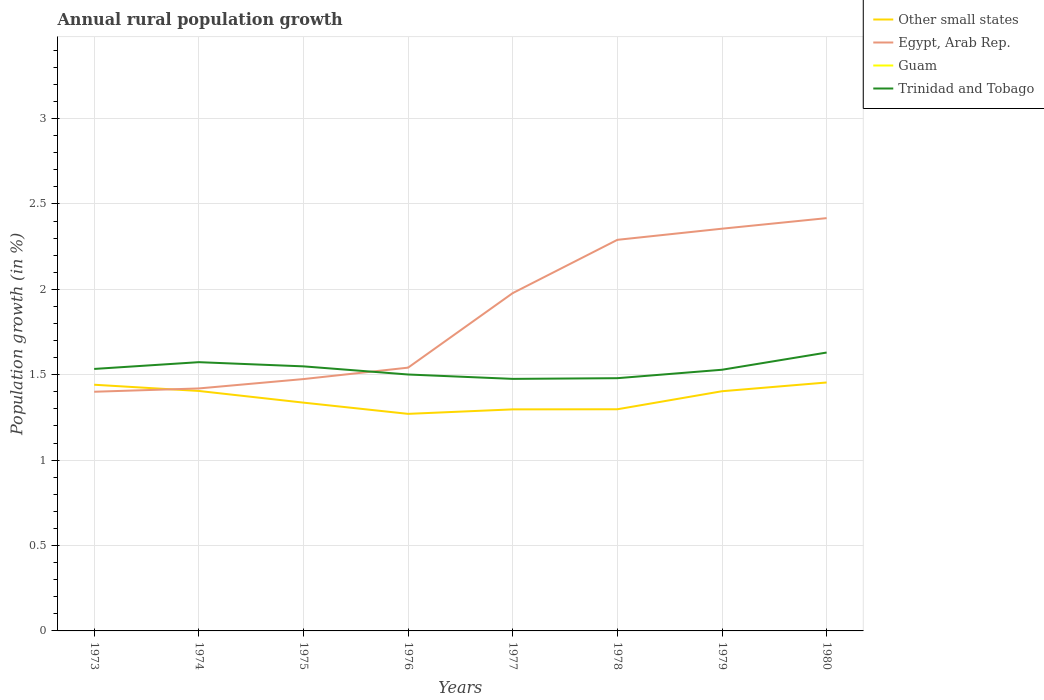How many different coloured lines are there?
Your response must be concise. 3. Across all years, what is the maximum percentage of rural population growth in Trinidad and Tobago?
Offer a very short reply. 1.48. What is the total percentage of rural population growth in Egypt, Arab Rep. in the graph?
Give a very brief answer. -0.07. What is the difference between the highest and the second highest percentage of rural population growth in Egypt, Arab Rep.?
Make the answer very short. 1.02. What is the difference between the highest and the lowest percentage of rural population growth in Trinidad and Tobago?
Give a very brief answer. 3. What is the difference between two consecutive major ticks on the Y-axis?
Give a very brief answer. 0.5. Does the graph contain any zero values?
Give a very brief answer. Yes. Does the graph contain grids?
Provide a succinct answer. Yes. Where does the legend appear in the graph?
Keep it short and to the point. Top right. How many legend labels are there?
Your answer should be compact. 4. What is the title of the graph?
Provide a short and direct response. Annual rural population growth. What is the label or title of the Y-axis?
Your answer should be compact. Population growth (in %). What is the Population growth (in %) in Other small states in 1973?
Give a very brief answer. 1.44. What is the Population growth (in %) of Egypt, Arab Rep. in 1973?
Keep it short and to the point. 1.4. What is the Population growth (in %) of Guam in 1973?
Give a very brief answer. 0. What is the Population growth (in %) in Trinidad and Tobago in 1973?
Ensure brevity in your answer.  1.53. What is the Population growth (in %) in Other small states in 1974?
Ensure brevity in your answer.  1.41. What is the Population growth (in %) of Egypt, Arab Rep. in 1974?
Ensure brevity in your answer.  1.42. What is the Population growth (in %) of Guam in 1974?
Your answer should be very brief. 0. What is the Population growth (in %) of Trinidad and Tobago in 1974?
Offer a terse response. 1.57. What is the Population growth (in %) of Other small states in 1975?
Provide a succinct answer. 1.34. What is the Population growth (in %) in Egypt, Arab Rep. in 1975?
Offer a very short reply. 1.47. What is the Population growth (in %) in Trinidad and Tobago in 1975?
Your answer should be compact. 1.55. What is the Population growth (in %) in Other small states in 1976?
Keep it short and to the point. 1.27. What is the Population growth (in %) in Egypt, Arab Rep. in 1976?
Give a very brief answer. 1.54. What is the Population growth (in %) of Trinidad and Tobago in 1976?
Your answer should be compact. 1.5. What is the Population growth (in %) of Other small states in 1977?
Provide a succinct answer. 1.3. What is the Population growth (in %) in Egypt, Arab Rep. in 1977?
Your answer should be compact. 1.98. What is the Population growth (in %) of Guam in 1977?
Give a very brief answer. 0. What is the Population growth (in %) in Trinidad and Tobago in 1977?
Offer a terse response. 1.48. What is the Population growth (in %) in Other small states in 1978?
Your response must be concise. 1.3. What is the Population growth (in %) of Egypt, Arab Rep. in 1978?
Provide a short and direct response. 2.29. What is the Population growth (in %) of Trinidad and Tobago in 1978?
Your answer should be compact. 1.48. What is the Population growth (in %) of Other small states in 1979?
Offer a very short reply. 1.4. What is the Population growth (in %) in Egypt, Arab Rep. in 1979?
Your answer should be compact. 2.36. What is the Population growth (in %) of Guam in 1979?
Your response must be concise. 0. What is the Population growth (in %) of Trinidad and Tobago in 1979?
Your answer should be very brief. 1.53. What is the Population growth (in %) in Other small states in 1980?
Keep it short and to the point. 1.45. What is the Population growth (in %) in Egypt, Arab Rep. in 1980?
Offer a terse response. 2.42. What is the Population growth (in %) of Guam in 1980?
Offer a terse response. 0. What is the Population growth (in %) in Trinidad and Tobago in 1980?
Give a very brief answer. 1.63. Across all years, what is the maximum Population growth (in %) in Other small states?
Your answer should be very brief. 1.45. Across all years, what is the maximum Population growth (in %) of Egypt, Arab Rep.?
Make the answer very short. 2.42. Across all years, what is the maximum Population growth (in %) in Trinidad and Tobago?
Provide a short and direct response. 1.63. Across all years, what is the minimum Population growth (in %) in Other small states?
Make the answer very short. 1.27. Across all years, what is the minimum Population growth (in %) in Egypt, Arab Rep.?
Ensure brevity in your answer.  1.4. Across all years, what is the minimum Population growth (in %) of Trinidad and Tobago?
Keep it short and to the point. 1.48. What is the total Population growth (in %) in Other small states in the graph?
Your answer should be compact. 10.91. What is the total Population growth (in %) of Egypt, Arab Rep. in the graph?
Give a very brief answer. 14.88. What is the total Population growth (in %) of Guam in the graph?
Your answer should be very brief. 0. What is the total Population growth (in %) in Trinidad and Tobago in the graph?
Offer a terse response. 12.27. What is the difference between the Population growth (in %) of Other small states in 1973 and that in 1974?
Give a very brief answer. 0.04. What is the difference between the Population growth (in %) in Egypt, Arab Rep. in 1973 and that in 1974?
Make the answer very short. -0.02. What is the difference between the Population growth (in %) in Trinidad and Tobago in 1973 and that in 1974?
Offer a terse response. -0.04. What is the difference between the Population growth (in %) of Other small states in 1973 and that in 1975?
Your answer should be compact. 0.1. What is the difference between the Population growth (in %) of Egypt, Arab Rep. in 1973 and that in 1975?
Offer a terse response. -0.07. What is the difference between the Population growth (in %) of Trinidad and Tobago in 1973 and that in 1975?
Offer a terse response. -0.02. What is the difference between the Population growth (in %) in Other small states in 1973 and that in 1976?
Your answer should be very brief. 0.17. What is the difference between the Population growth (in %) in Egypt, Arab Rep. in 1973 and that in 1976?
Your answer should be very brief. -0.14. What is the difference between the Population growth (in %) of Trinidad and Tobago in 1973 and that in 1976?
Your answer should be very brief. 0.03. What is the difference between the Population growth (in %) in Other small states in 1973 and that in 1977?
Keep it short and to the point. 0.14. What is the difference between the Population growth (in %) in Egypt, Arab Rep. in 1973 and that in 1977?
Provide a short and direct response. -0.58. What is the difference between the Population growth (in %) of Trinidad and Tobago in 1973 and that in 1977?
Provide a short and direct response. 0.06. What is the difference between the Population growth (in %) of Other small states in 1973 and that in 1978?
Make the answer very short. 0.14. What is the difference between the Population growth (in %) in Egypt, Arab Rep. in 1973 and that in 1978?
Offer a terse response. -0.89. What is the difference between the Population growth (in %) in Trinidad and Tobago in 1973 and that in 1978?
Provide a short and direct response. 0.05. What is the difference between the Population growth (in %) in Other small states in 1973 and that in 1979?
Keep it short and to the point. 0.04. What is the difference between the Population growth (in %) of Egypt, Arab Rep. in 1973 and that in 1979?
Your response must be concise. -0.95. What is the difference between the Population growth (in %) in Trinidad and Tobago in 1973 and that in 1979?
Provide a succinct answer. 0. What is the difference between the Population growth (in %) in Other small states in 1973 and that in 1980?
Give a very brief answer. -0.01. What is the difference between the Population growth (in %) of Egypt, Arab Rep. in 1973 and that in 1980?
Offer a terse response. -1.02. What is the difference between the Population growth (in %) in Trinidad and Tobago in 1973 and that in 1980?
Your answer should be compact. -0.1. What is the difference between the Population growth (in %) of Other small states in 1974 and that in 1975?
Keep it short and to the point. 0.07. What is the difference between the Population growth (in %) in Egypt, Arab Rep. in 1974 and that in 1975?
Your answer should be very brief. -0.05. What is the difference between the Population growth (in %) in Trinidad and Tobago in 1974 and that in 1975?
Make the answer very short. 0.02. What is the difference between the Population growth (in %) in Other small states in 1974 and that in 1976?
Make the answer very short. 0.13. What is the difference between the Population growth (in %) of Egypt, Arab Rep. in 1974 and that in 1976?
Keep it short and to the point. -0.12. What is the difference between the Population growth (in %) in Trinidad and Tobago in 1974 and that in 1976?
Your answer should be compact. 0.07. What is the difference between the Population growth (in %) of Other small states in 1974 and that in 1977?
Your answer should be compact. 0.11. What is the difference between the Population growth (in %) in Egypt, Arab Rep. in 1974 and that in 1977?
Your answer should be very brief. -0.56. What is the difference between the Population growth (in %) of Trinidad and Tobago in 1974 and that in 1977?
Offer a very short reply. 0.1. What is the difference between the Population growth (in %) in Other small states in 1974 and that in 1978?
Offer a terse response. 0.11. What is the difference between the Population growth (in %) of Egypt, Arab Rep. in 1974 and that in 1978?
Keep it short and to the point. -0.87. What is the difference between the Population growth (in %) in Trinidad and Tobago in 1974 and that in 1978?
Your answer should be compact. 0.09. What is the difference between the Population growth (in %) in Other small states in 1974 and that in 1979?
Ensure brevity in your answer.  0. What is the difference between the Population growth (in %) of Egypt, Arab Rep. in 1974 and that in 1979?
Give a very brief answer. -0.94. What is the difference between the Population growth (in %) of Trinidad and Tobago in 1974 and that in 1979?
Provide a succinct answer. 0.04. What is the difference between the Population growth (in %) of Other small states in 1974 and that in 1980?
Ensure brevity in your answer.  -0.05. What is the difference between the Population growth (in %) of Egypt, Arab Rep. in 1974 and that in 1980?
Your response must be concise. -1. What is the difference between the Population growth (in %) in Trinidad and Tobago in 1974 and that in 1980?
Keep it short and to the point. -0.06. What is the difference between the Population growth (in %) in Other small states in 1975 and that in 1976?
Your answer should be very brief. 0.07. What is the difference between the Population growth (in %) of Egypt, Arab Rep. in 1975 and that in 1976?
Your answer should be very brief. -0.07. What is the difference between the Population growth (in %) in Trinidad and Tobago in 1975 and that in 1976?
Give a very brief answer. 0.05. What is the difference between the Population growth (in %) in Other small states in 1975 and that in 1977?
Give a very brief answer. 0.04. What is the difference between the Population growth (in %) of Egypt, Arab Rep. in 1975 and that in 1977?
Your answer should be compact. -0.5. What is the difference between the Population growth (in %) of Trinidad and Tobago in 1975 and that in 1977?
Your answer should be very brief. 0.07. What is the difference between the Population growth (in %) in Other small states in 1975 and that in 1978?
Your answer should be very brief. 0.04. What is the difference between the Population growth (in %) in Egypt, Arab Rep. in 1975 and that in 1978?
Ensure brevity in your answer.  -0.82. What is the difference between the Population growth (in %) in Trinidad and Tobago in 1975 and that in 1978?
Keep it short and to the point. 0.07. What is the difference between the Population growth (in %) of Other small states in 1975 and that in 1979?
Provide a short and direct response. -0.07. What is the difference between the Population growth (in %) in Egypt, Arab Rep. in 1975 and that in 1979?
Offer a terse response. -0.88. What is the difference between the Population growth (in %) in Trinidad and Tobago in 1975 and that in 1979?
Your answer should be compact. 0.02. What is the difference between the Population growth (in %) of Other small states in 1975 and that in 1980?
Provide a short and direct response. -0.12. What is the difference between the Population growth (in %) of Egypt, Arab Rep. in 1975 and that in 1980?
Make the answer very short. -0.94. What is the difference between the Population growth (in %) in Trinidad and Tobago in 1975 and that in 1980?
Your answer should be compact. -0.08. What is the difference between the Population growth (in %) in Other small states in 1976 and that in 1977?
Offer a very short reply. -0.03. What is the difference between the Population growth (in %) in Egypt, Arab Rep. in 1976 and that in 1977?
Provide a succinct answer. -0.44. What is the difference between the Population growth (in %) in Trinidad and Tobago in 1976 and that in 1977?
Ensure brevity in your answer.  0.03. What is the difference between the Population growth (in %) in Other small states in 1976 and that in 1978?
Provide a short and direct response. -0.03. What is the difference between the Population growth (in %) of Egypt, Arab Rep. in 1976 and that in 1978?
Ensure brevity in your answer.  -0.75. What is the difference between the Population growth (in %) in Trinidad and Tobago in 1976 and that in 1978?
Keep it short and to the point. 0.02. What is the difference between the Population growth (in %) of Other small states in 1976 and that in 1979?
Provide a succinct answer. -0.13. What is the difference between the Population growth (in %) of Egypt, Arab Rep. in 1976 and that in 1979?
Provide a short and direct response. -0.81. What is the difference between the Population growth (in %) in Trinidad and Tobago in 1976 and that in 1979?
Keep it short and to the point. -0.03. What is the difference between the Population growth (in %) of Other small states in 1976 and that in 1980?
Provide a succinct answer. -0.18. What is the difference between the Population growth (in %) of Egypt, Arab Rep. in 1976 and that in 1980?
Make the answer very short. -0.88. What is the difference between the Population growth (in %) of Trinidad and Tobago in 1976 and that in 1980?
Your response must be concise. -0.13. What is the difference between the Population growth (in %) in Other small states in 1977 and that in 1978?
Provide a succinct answer. -0. What is the difference between the Population growth (in %) of Egypt, Arab Rep. in 1977 and that in 1978?
Provide a short and direct response. -0.31. What is the difference between the Population growth (in %) in Trinidad and Tobago in 1977 and that in 1978?
Ensure brevity in your answer.  -0. What is the difference between the Population growth (in %) of Other small states in 1977 and that in 1979?
Offer a terse response. -0.11. What is the difference between the Population growth (in %) of Egypt, Arab Rep. in 1977 and that in 1979?
Ensure brevity in your answer.  -0.38. What is the difference between the Population growth (in %) of Trinidad and Tobago in 1977 and that in 1979?
Keep it short and to the point. -0.05. What is the difference between the Population growth (in %) in Other small states in 1977 and that in 1980?
Your answer should be very brief. -0.16. What is the difference between the Population growth (in %) in Egypt, Arab Rep. in 1977 and that in 1980?
Provide a succinct answer. -0.44. What is the difference between the Population growth (in %) of Trinidad and Tobago in 1977 and that in 1980?
Your answer should be very brief. -0.15. What is the difference between the Population growth (in %) of Other small states in 1978 and that in 1979?
Offer a terse response. -0.11. What is the difference between the Population growth (in %) of Egypt, Arab Rep. in 1978 and that in 1979?
Offer a terse response. -0.07. What is the difference between the Population growth (in %) of Trinidad and Tobago in 1978 and that in 1979?
Offer a very short reply. -0.05. What is the difference between the Population growth (in %) in Other small states in 1978 and that in 1980?
Offer a very short reply. -0.16. What is the difference between the Population growth (in %) in Egypt, Arab Rep. in 1978 and that in 1980?
Make the answer very short. -0.13. What is the difference between the Population growth (in %) of Trinidad and Tobago in 1978 and that in 1980?
Provide a succinct answer. -0.15. What is the difference between the Population growth (in %) in Other small states in 1979 and that in 1980?
Make the answer very short. -0.05. What is the difference between the Population growth (in %) in Egypt, Arab Rep. in 1979 and that in 1980?
Provide a short and direct response. -0.06. What is the difference between the Population growth (in %) of Trinidad and Tobago in 1979 and that in 1980?
Give a very brief answer. -0.1. What is the difference between the Population growth (in %) in Other small states in 1973 and the Population growth (in %) in Egypt, Arab Rep. in 1974?
Give a very brief answer. 0.02. What is the difference between the Population growth (in %) of Other small states in 1973 and the Population growth (in %) of Trinidad and Tobago in 1974?
Provide a short and direct response. -0.13. What is the difference between the Population growth (in %) in Egypt, Arab Rep. in 1973 and the Population growth (in %) in Trinidad and Tobago in 1974?
Offer a terse response. -0.17. What is the difference between the Population growth (in %) in Other small states in 1973 and the Population growth (in %) in Egypt, Arab Rep. in 1975?
Your response must be concise. -0.03. What is the difference between the Population growth (in %) of Other small states in 1973 and the Population growth (in %) of Trinidad and Tobago in 1975?
Give a very brief answer. -0.11. What is the difference between the Population growth (in %) of Egypt, Arab Rep. in 1973 and the Population growth (in %) of Trinidad and Tobago in 1975?
Give a very brief answer. -0.15. What is the difference between the Population growth (in %) of Other small states in 1973 and the Population growth (in %) of Egypt, Arab Rep. in 1976?
Offer a very short reply. -0.1. What is the difference between the Population growth (in %) of Other small states in 1973 and the Population growth (in %) of Trinidad and Tobago in 1976?
Make the answer very short. -0.06. What is the difference between the Population growth (in %) of Egypt, Arab Rep. in 1973 and the Population growth (in %) of Trinidad and Tobago in 1976?
Ensure brevity in your answer.  -0.1. What is the difference between the Population growth (in %) in Other small states in 1973 and the Population growth (in %) in Egypt, Arab Rep. in 1977?
Keep it short and to the point. -0.54. What is the difference between the Population growth (in %) of Other small states in 1973 and the Population growth (in %) of Trinidad and Tobago in 1977?
Keep it short and to the point. -0.03. What is the difference between the Population growth (in %) in Egypt, Arab Rep. in 1973 and the Population growth (in %) in Trinidad and Tobago in 1977?
Provide a short and direct response. -0.08. What is the difference between the Population growth (in %) in Other small states in 1973 and the Population growth (in %) in Egypt, Arab Rep. in 1978?
Provide a succinct answer. -0.85. What is the difference between the Population growth (in %) of Other small states in 1973 and the Population growth (in %) of Trinidad and Tobago in 1978?
Keep it short and to the point. -0.04. What is the difference between the Population growth (in %) in Egypt, Arab Rep. in 1973 and the Population growth (in %) in Trinidad and Tobago in 1978?
Offer a very short reply. -0.08. What is the difference between the Population growth (in %) of Other small states in 1973 and the Population growth (in %) of Egypt, Arab Rep. in 1979?
Offer a very short reply. -0.91. What is the difference between the Population growth (in %) in Other small states in 1973 and the Population growth (in %) in Trinidad and Tobago in 1979?
Your answer should be very brief. -0.09. What is the difference between the Population growth (in %) of Egypt, Arab Rep. in 1973 and the Population growth (in %) of Trinidad and Tobago in 1979?
Make the answer very short. -0.13. What is the difference between the Population growth (in %) of Other small states in 1973 and the Population growth (in %) of Egypt, Arab Rep. in 1980?
Keep it short and to the point. -0.98. What is the difference between the Population growth (in %) of Other small states in 1973 and the Population growth (in %) of Trinidad and Tobago in 1980?
Keep it short and to the point. -0.19. What is the difference between the Population growth (in %) in Egypt, Arab Rep. in 1973 and the Population growth (in %) in Trinidad and Tobago in 1980?
Your answer should be very brief. -0.23. What is the difference between the Population growth (in %) in Other small states in 1974 and the Population growth (in %) in Egypt, Arab Rep. in 1975?
Offer a very short reply. -0.07. What is the difference between the Population growth (in %) in Other small states in 1974 and the Population growth (in %) in Trinidad and Tobago in 1975?
Your answer should be compact. -0.14. What is the difference between the Population growth (in %) of Egypt, Arab Rep. in 1974 and the Population growth (in %) of Trinidad and Tobago in 1975?
Offer a very short reply. -0.13. What is the difference between the Population growth (in %) in Other small states in 1974 and the Population growth (in %) in Egypt, Arab Rep. in 1976?
Provide a short and direct response. -0.14. What is the difference between the Population growth (in %) of Other small states in 1974 and the Population growth (in %) of Trinidad and Tobago in 1976?
Your answer should be very brief. -0.1. What is the difference between the Population growth (in %) of Egypt, Arab Rep. in 1974 and the Population growth (in %) of Trinidad and Tobago in 1976?
Ensure brevity in your answer.  -0.08. What is the difference between the Population growth (in %) of Other small states in 1974 and the Population growth (in %) of Egypt, Arab Rep. in 1977?
Your answer should be compact. -0.57. What is the difference between the Population growth (in %) of Other small states in 1974 and the Population growth (in %) of Trinidad and Tobago in 1977?
Make the answer very short. -0.07. What is the difference between the Population growth (in %) of Egypt, Arab Rep. in 1974 and the Population growth (in %) of Trinidad and Tobago in 1977?
Keep it short and to the point. -0.06. What is the difference between the Population growth (in %) of Other small states in 1974 and the Population growth (in %) of Egypt, Arab Rep. in 1978?
Your answer should be compact. -0.89. What is the difference between the Population growth (in %) in Other small states in 1974 and the Population growth (in %) in Trinidad and Tobago in 1978?
Your response must be concise. -0.07. What is the difference between the Population growth (in %) in Egypt, Arab Rep. in 1974 and the Population growth (in %) in Trinidad and Tobago in 1978?
Give a very brief answer. -0.06. What is the difference between the Population growth (in %) of Other small states in 1974 and the Population growth (in %) of Egypt, Arab Rep. in 1979?
Your response must be concise. -0.95. What is the difference between the Population growth (in %) of Other small states in 1974 and the Population growth (in %) of Trinidad and Tobago in 1979?
Keep it short and to the point. -0.12. What is the difference between the Population growth (in %) of Egypt, Arab Rep. in 1974 and the Population growth (in %) of Trinidad and Tobago in 1979?
Offer a very short reply. -0.11. What is the difference between the Population growth (in %) in Other small states in 1974 and the Population growth (in %) in Egypt, Arab Rep. in 1980?
Your answer should be very brief. -1.01. What is the difference between the Population growth (in %) of Other small states in 1974 and the Population growth (in %) of Trinidad and Tobago in 1980?
Provide a short and direct response. -0.23. What is the difference between the Population growth (in %) in Egypt, Arab Rep. in 1974 and the Population growth (in %) in Trinidad and Tobago in 1980?
Give a very brief answer. -0.21. What is the difference between the Population growth (in %) in Other small states in 1975 and the Population growth (in %) in Egypt, Arab Rep. in 1976?
Offer a terse response. -0.2. What is the difference between the Population growth (in %) of Other small states in 1975 and the Population growth (in %) of Trinidad and Tobago in 1976?
Provide a succinct answer. -0.16. What is the difference between the Population growth (in %) of Egypt, Arab Rep. in 1975 and the Population growth (in %) of Trinidad and Tobago in 1976?
Provide a short and direct response. -0.03. What is the difference between the Population growth (in %) of Other small states in 1975 and the Population growth (in %) of Egypt, Arab Rep. in 1977?
Offer a very short reply. -0.64. What is the difference between the Population growth (in %) of Other small states in 1975 and the Population growth (in %) of Trinidad and Tobago in 1977?
Ensure brevity in your answer.  -0.14. What is the difference between the Population growth (in %) in Egypt, Arab Rep. in 1975 and the Population growth (in %) in Trinidad and Tobago in 1977?
Keep it short and to the point. -0. What is the difference between the Population growth (in %) of Other small states in 1975 and the Population growth (in %) of Egypt, Arab Rep. in 1978?
Make the answer very short. -0.95. What is the difference between the Population growth (in %) of Other small states in 1975 and the Population growth (in %) of Trinidad and Tobago in 1978?
Your response must be concise. -0.14. What is the difference between the Population growth (in %) of Egypt, Arab Rep. in 1975 and the Population growth (in %) of Trinidad and Tobago in 1978?
Offer a very short reply. -0.01. What is the difference between the Population growth (in %) of Other small states in 1975 and the Population growth (in %) of Egypt, Arab Rep. in 1979?
Give a very brief answer. -1.02. What is the difference between the Population growth (in %) in Other small states in 1975 and the Population growth (in %) in Trinidad and Tobago in 1979?
Offer a terse response. -0.19. What is the difference between the Population growth (in %) of Egypt, Arab Rep. in 1975 and the Population growth (in %) of Trinidad and Tobago in 1979?
Keep it short and to the point. -0.05. What is the difference between the Population growth (in %) of Other small states in 1975 and the Population growth (in %) of Egypt, Arab Rep. in 1980?
Offer a very short reply. -1.08. What is the difference between the Population growth (in %) in Other small states in 1975 and the Population growth (in %) in Trinidad and Tobago in 1980?
Ensure brevity in your answer.  -0.29. What is the difference between the Population growth (in %) of Egypt, Arab Rep. in 1975 and the Population growth (in %) of Trinidad and Tobago in 1980?
Ensure brevity in your answer.  -0.16. What is the difference between the Population growth (in %) of Other small states in 1976 and the Population growth (in %) of Egypt, Arab Rep. in 1977?
Give a very brief answer. -0.71. What is the difference between the Population growth (in %) of Other small states in 1976 and the Population growth (in %) of Trinidad and Tobago in 1977?
Ensure brevity in your answer.  -0.2. What is the difference between the Population growth (in %) of Egypt, Arab Rep. in 1976 and the Population growth (in %) of Trinidad and Tobago in 1977?
Your answer should be compact. 0.07. What is the difference between the Population growth (in %) of Other small states in 1976 and the Population growth (in %) of Egypt, Arab Rep. in 1978?
Provide a succinct answer. -1.02. What is the difference between the Population growth (in %) of Other small states in 1976 and the Population growth (in %) of Trinidad and Tobago in 1978?
Your response must be concise. -0.21. What is the difference between the Population growth (in %) in Egypt, Arab Rep. in 1976 and the Population growth (in %) in Trinidad and Tobago in 1978?
Offer a very short reply. 0.06. What is the difference between the Population growth (in %) of Other small states in 1976 and the Population growth (in %) of Egypt, Arab Rep. in 1979?
Provide a succinct answer. -1.08. What is the difference between the Population growth (in %) in Other small states in 1976 and the Population growth (in %) in Trinidad and Tobago in 1979?
Provide a succinct answer. -0.26. What is the difference between the Population growth (in %) of Egypt, Arab Rep. in 1976 and the Population growth (in %) of Trinidad and Tobago in 1979?
Your response must be concise. 0.01. What is the difference between the Population growth (in %) in Other small states in 1976 and the Population growth (in %) in Egypt, Arab Rep. in 1980?
Provide a short and direct response. -1.15. What is the difference between the Population growth (in %) of Other small states in 1976 and the Population growth (in %) of Trinidad and Tobago in 1980?
Ensure brevity in your answer.  -0.36. What is the difference between the Population growth (in %) in Egypt, Arab Rep. in 1976 and the Population growth (in %) in Trinidad and Tobago in 1980?
Provide a succinct answer. -0.09. What is the difference between the Population growth (in %) of Other small states in 1977 and the Population growth (in %) of Egypt, Arab Rep. in 1978?
Your answer should be very brief. -0.99. What is the difference between the Population growth (in %) in Other small states in 1977 and the Population growth (in %) in Trinidad and Tobago in 1978?
Make the answer very short. -0.18. What is the difference between the Population growth (in %) of Egypt, Arab Rep. in 1977 and the Population growth (in %) of Trinidad and Tobago in 1978?
Provide a short and direct response. 0.5. What is the difference between the Population growth (in %) in Other small states in 1977 and the Population growth (in %) in Egypt, Arab Rep. in 1979?
Offer a terse response. -1.06. What is the difference between the Population growth (in %) of Other small states in 1977 and the Population growth (in %) of Trinidad and Tobago in 1979?
Give a very brief answer. -0.23. What is the difference between the Population growth (in %) of Egypt, Arab Rep. in 1977 and the Population growth (in %) of Trinidad and Tobago in 1979?
Your answer should be very brief. 0.45. What is the difference between the Population growth (in %) of Other small states in 1977 and the Population growth (in %) of Egypt, Arab Rep. in 1980?
Provide a succinct answer. -1.12. What is the difference between the Population growth (in %) of Other small states in 1977 and the Population growth (in %) of Trinidad and Tobago in 1980?
Offer a very short reply. -0.33. What is the difference between the Population growth (in %) in Egypt, Arab Rep. in 1977 and the Population growth (in %) in Trinidad and Tobago in 1980?
Offer a very short reply. 0.35. What is the difference between the Population growth (in %) in Other small states in 1978 and the Population growth (in %) in Egypt, Arab Rep. in 1979?
Make the answer very short. -1.06. What is the difference between the Population growth (in %) in Other small states in 1978 and the Population growth (in %) in Trinidad and Tobago in 1979?
Your answer should be compact. -0.23. What is the difference between the Population growth (in %) in Egypt, Arab Rep. in 1978 and the Population growth (in %) in Trinidad and Tobago in 1979?
Give a very brief answer. 0.76. What is the difference between the Population growth (in %) of Other small states in 1978 and the Population growth (in %) of Egypt, Arab Rep. in 1980?
Give a very brief answer. -1.12. What is the difference between the Population growth (in %) of Other small states in 1978 and the Population growth (in %) of Trinidad and Tobago in 1980?
Your answer should be compact. -0.33. What is the difference between the Population growth (in %) in Egypt, Arab Rep. in 1978 and the Population growth (in %) in Trinidad and Tobago in 1980?
Make the answer very short. 0.66. What is the difference between the Population growth (in %) of Other small states in 1979 and the Population growth (in %) of Egypt, Arab Rep. in 1980?
Offer a very short reply. -1.01. What is the difference between the Population growth (in %) in Other small states in 1979 and the Population growth (in %) in Trinidad and Tobago in 1980?
Offer a very short reply. -0.23. What is the difference between the Population growth (in %) of Egypt, Arab Rep. in 1979 and the Population growth (in %) of Trinidad and Tobago in 1980?
Ensure brevity in your answer.  0.73. What is the average Population growth (in %) in Other small states per year?
Your answer should be compact. 1.36. What is the average Population growth (in %) in Egypt, Arab Rep. per year?
Provide a succinct answer. 1.86. What is the average Population growth (in %) of Trinidad and Tobago per year?
Keep it short and to the point. 1.53. In the year 1973, what is the difference between the Population growth (in %) in Other small states and Population growth (in %) in Egypt, Arab Rep.?
Keep it short and to the point. 0.04. In the year 1973, what is the difference between the Population growth (in %) of Other small states and Population growth (in %) of Trinidad and Tobago?
Your answer should be very brief. -0.09. In the year 1973, what is the difference between the Population growth (in %) in Egypt, Arab Rep. and Population growth (in %) in Trinidad and Tobago?
Make the answer very short. -0.13. In the year 1974, what is the difference between the Population growth (in %) of Other small states and Population growth (in %) of Egypt, Arab Rep.?
Your answer should be very brief. -0.01. In the year 1974, what is the difference between the Population growth (in %) of Other small states and Population growth (in %) of Trinidad and Tobago?
Offer a terse response. -0.17. In the year 1974, what is the difference between the Population growth (in %) of Egypt, Arab Rep. and Population growth (in %) of Trinidad and Tobago?
Ensure brevity in your answer.  -0.15. In the year 1975, what is the difference between the Population growth (in %) in Other small states and Population growth (in %) in Egypt, Arab Rep.?
Give a very brief answer. -0.14. In the year 1975, what is the difference between the Population growth (in %) of Other small states and Population growth (in %) of Trinidad and Tobago?
Ensure brevity in your answer.  -0.21. In the year 1975, what is the difference between the Population growth (in %) of Egypt, Arab Rep. and Population growth (in %) of Trinidad and Tobago?
Make the answer very short. -0.07. In the year 1976, what is the difference between the Population growth (in %) of Other small states and Population growth (in %) of Egypt, Arab Rep.?
Offer a terse response. -0.27. In the year 1976, what is the difference between the Population growth (in %) of Other small states and Population growth (in %) of Trinidad and Tobago?
Your response must be concise. -0.23. In the year 1976, what is the difference between the Population growth (in %) of Egypt, Arab Rep. and Population growth (in %) of Trinidad and Tobago?
Give a very brief answer. 0.04. In the year 1977, what is the difference between the Population growth (in %) of Other small states and Population growth (in %) of Egypt, Arab Rep.?
Ensure brevity in your answer.  -0.68. In the year 1977, what is the difference between the Population growth (in %) of Other small states and Population growth (in %) of Trinidad and Tobago?
Keep it short and to the point. -0.18. In the year 1977, what is the difference between the Population growth (in %) in Egypt, Arab Rep. and Population growth (in %) in Trinidad and Tobago?
Make the answer very short. 0.5. In the year 1978, what is the difference between the Population growth (in %) of Other small states and Population growth (in %) of Egypt, Arab Rep.?
Offer a very short reply. -0.99. In the year 1978, what is the difference between the Population growth (in %) of Other small states and Population growth (in %) of Trinidad and Tobago?
Offer a very short reply. -0.18. In the year 1978, what is the difference between the Population growth (in %) of Egypt, Arab Rep. and Population growth (in %) of Trinidad and Tobago?
Make the answer very short. 0.81. In the year 1979, what is the difference between the Population growth (in %) in Other small states and Population growth (in %) in Egypt, Arab Rep.?
Keep it short and to the point. -0.95. In the year 1979, what is the difference between the Population growth (in %) in Other small states and Population growth (in %) in Trinidad and Tobago?
Provide a short and direct response. -0.13. In the year 1979, what is the difference between the Population growth (in %) of Egypt, Arab Rep. and Population growth (in %) of Trinidad and Tobago?
Provide a short and direct response. 0.83. In the year 1980, what is the difference between the Population growth (in %) in Other small states and Population growth (in %) in Egypt, Arab Rep.?
Ensure brevity in your answer.  -0.96. In the year 1980, what is the difference between the Population growth (in %) in Other small states and Population growth (in %) in Trinidad and Tobago?
Provide a short and direct response. -0.18. In the year 1980, what is the difference between the Population growth (in %) in Egypt, Arab Rep. and Population growth (in %) in Trinidad and Tobago?
Offer a terse response. 0.79. What is the ratio of the Population growth (in %) in Other small states in 1973 to that in 1974?
Your answer should be compact. 1.03. What is the ratio of the Population growth (in %) of Egypt, Arab Rep. in 1973 to that in 1974?
Your response must be concise. 0.99. What is the ratio of the Population growth (in %) in Trinidad and Tobago in 1973 to that in 1974?
Ensure brevity in your answer.  0.97. What is the ratio of the Population growth (in %) in Other small states in 1973 to that in 1975?
Your answer should be very brief. 1.08. What is the ratio of the Population growth (in %) in Egypt, Arab Rep. in 1973 to that in 1975?
Your response must be concise. 0.95. What is the ratio of the Population growth (in %) in Trinidad and Tobago in 1973 to that in 1975?
Give a very brief answer. 0.99. What is the ratio of the Population growth (in %) of Other small states in 1973 to that in 1976?
Give a very brief answer. 1.13. What is the ratio of the Population growth (in %) of Egypt, Arab Rep. in 1973 to that in 1976?
Provide a short and direct response. 0.91. What is the ratio of the Population growth (in %) in Trinidad and Tobago in 1973 to that in 1976?
Ensure brevity in your answer.  1.02. What is the ratio of the Population growth (in %) in Other small states in 1973 to that in 1977?
Provide a short and direct response. 1.11. What is the ratio of the Population growth (in %) in Egypt, Arab Rep. in 1973 to that in 1977?
Ensure brevity in your answer.  0.71. What is the ratio of the Population growth (in %) of Trinidad and Tobago in 1973 to that in 1977?
Your answer should be very brief. 1.04. What is the ratio of the Population growth (in %) of Other small states in 1973 to that in 1978?
Offer a terse response. 1.11. What is the ratio of the Population growth (in %) in Egypt, Arab Rep. in 1973 to that in 1978?
Ensure brevity in your answer.  0.61. What is the ratio of the Population growth (in %) of Trinidad and Tobago in 1973 to that in 1978?
Provide a succinct answer. 1.04. What is the ratio of the Population growth (in %) in Other small states in 1973 to that in 1979?
Offer a very short reply. 1.03. What is the ratio of the Population growth (in %) of Egypt, Arab Rep. in 1973 to that in 1979?
Offer a very short reply. 0.59. What is the ratio of the Population growth (in %) of Trinidad and Tobago in 1973 to that in 1979?
Your response must be concise. 1. What is the ratio of the Population growth (in %) of Egypt, Arab Rep. in 1973 to that in 1980?
Ensure brevity in your answer.  0.58. What is the ratio of the Population growth (in %) of Trinidad and Tobago in 1973 to that in 1980?
Offer a terse response. 0.94. What is the ratio of the Population growth (in %) in Other small states in 1974 to that in 1975?
Ensure brevity in your answer.  1.05. What is the ratio of the Population growth (in %) of Egypt, Arab Rep. in 1974 to that in 1975?
Your answer should be compact. 0.96. What is the ratio of the Population growth (in %) of Trinidad and Tobago in 1974 to that in 1975?
Your answer should be very brief. 1.02. What is the ratio of the Population growth (in %) in Other small states in 1974 to that in 1976?
Offer a very short reply. 1.11. What is the ratio of the Population growth (in %) in Egypt, Arab Rep. in 1974 to that in 1976?
Provide a short and direct response. 0.92. What is the ratio of the Population growth (in %) of Trinidad and Tobago in 1974 to that in 1976?
Your answer should be compact. 1.05. What is the ratio of the Population growth (in %) of Other small states in 1974 to that in 1977?
Keep it short and to the point. 1.08. What is the ratio of the Population growth (in %) in Egypt, Arab Rep. in 1974 to that in 1977?
Offer a terse response. 0.72. What is the ratio of the Population growth (in %) of Trinidad and Tobago in 1974 to that in 1977?
Provide a short and direct response. 1.07. What is the ratio of the Population growth (in %) in Other small states in 1974 to that in 1978?
Your response must be concise. 1.08. What is the ratio of the Population growth (in %) of Egypt, Arab Rep. in 1974 to that in 1978?
Offer a terse response. 0.62. What is the ratio of the Population growth (in %) in Trinidad and Tobago in 1974 to that in 1978?
Give a very brief answer. 1.06. What is the ratio of the Population growth (in %) of Egypt, Arab Rep. in 1974 to that in 1979?
Keep it short and to the point. 0.6. What is the ratio of the Population growth (in %) of Other small states in 1974 to that in 1980?
Ensure brevity in your answer.  0.97. What is the ratio of the Population growth (in %) in Egypt, Arab Rep. in 1974 to that in 1980?
Ensure brevity in your answer.  0.59. What is the ratio of the Population growth (in %) in Trinidad and Tobago in 1974 to that in 1980?
Provide a succinct answer. 0.97. What is the ratio of the Population growth (in %) of Other small states in 1975 to that in 1976?
Your answer should be compact. 1.05. What is the ratio of the Population growth (in %) in Egypt, Arab Rep. in 1975 to that in 1976?
Give a very brief answer. 0.96. What is the ratio of the Population growth (in %) in Trinidad and Tobago in 1975 to that in 1976?
Your answer should be very brief. 1.03. What is the ratio of the Population growth (in %) in Other small states in 1975 to that in 1977?
Provide a succinct answer. 1.03. What is the ratio of the Population growth (in %) in Egypt, Arab Rep. in 1975 to that in 1977?
Your response must be concise. 0.75. What is the ratio of the Population growth (in %) of Trinidad and Tobago in 1975 to that in 1977?
Your answer should be very brief. 1.05. What is the ratio of the Population growth (in %) of Other small states in 1975 to that in 1978?
Offer a terse response. 1.03. What is the ratio of the Population growth (in %) in Egypt, Arab Rep. in 1975 to that in 1978?
Your answer should be compact. 0.64. What is the ratio of the Population growth (in %) in Trinidad and Tobago in 1975 to that in 1978?
Your answer should be compact. 1.05. What is the ratio of the Population growth (in %) in Other small states in 1975 to that in 1979?
Provide a short and direct response. 0.95. What is the ratio of the Population growth (in %) in Egypt, Arab Rep. in 1975 to that in 1979?
Offer a terse response. 0.63. What is the ratio of the Population growth (in %) of Trinidad and Tobago in 1975 to that in 1979?
Ensure brevity in your answer.  1.01. What is the ratio of the Population growth (in %) of Other small states in 1975 to that in 1980?
Provide a succinct answer. 0.92. What is the ratio of the Population growth (in %) of Egypt, Arab Rep. in 1975 to that in 1980?
Your answer should be compact. 0.61. What is the ratio of the Population growth (in %) in Trinidad and Tobago in 1975 to that in 1980?
Offer a terse response. 0.95. What is the ratio of the Population growth (in %) in Other small states in 1976 to that in 1977?
Provide a succinct answer. 0.98. What is the ratio of the Population growth (in %) in Egypt, Arab Rep. in 1976 to that in 1977?
Make the answer very short. 0.78. What is the ratio of the Population growth (in %) in Trinidad and Tobago in 1976 to that in 1977?
Offer a terse response. 1.02. What is the ratio of the Population growth (in %) of Other small states in 1976 to that in 1978?
Keep it short and to the point. 0.98. What is the ratio of the Population growth (in %) in Egypt, Arab Rep. in 1976 to that in 1978?
Offer a very short reply. 0.67. What is the ratio of the Population growth (in %) of Trinidad and Tobago in 1976 to that in 1978?
Ensure brevity in your answer.  1.01. What is the ratio of the Population growth (in %) of Other small states in 1976 to that in 1979?
Offer a terse response. 0.91. What is the ratio of the Population growth (in %) in Egypt, Arab Rep. in 1976 to that in 1979?
Your answer should be very brief. 0.65. What is the ratio of the Population growth (in %) of Trinidad and Tobago in 1976 to that in 1979?
Provide a succinct answer. 0.98. What is the ratio of the Population growth (in %) in Other small states in 1976 to that in 1980?
Keep it short and to the point. 0.87. What is the ratio of the Population growth (in %) in Egypt, Arab Rep. in 1976 to that in 1980?
Ensure brevity in your answer.  0.64. What is the ratio of the Population growth (in %) of Trinidad and Tobago in 1976 to that in 1980?
Offer a very short reply. 0.92. What is the ratio of the Population growth (in %) of Egypt, Arab Rep. in 1977 to that in 1978?
Make the answer very short. 0.86. What is the ratio of the Population growth (in %) in Other small states in 1977 to that in 1979?
Keep it short and to the point. 0.92. What is the ratio of the Population growth (in %) in Egypt, Arab Rep. in 1977 to that in 1979?
Your answer should be very brief. 0.84. What is the ratio of the Population growth (in %) in Trinidad and Tobago in 1977 to that in 1979?
Ensure brevity in your answer.  0.97. What is the ratio of the Population growth (in %) in Other small states in 1977 to that in 1980?
Ensure brevity in your answer.  0.89. What is the ratio of the Population growth (in %) in Egypt, Arab Rep. in 1977 to that in 1980?
Ensure brevity in your answer.  0.82. What is the ratio of the Population growth (in %) in Trinidad and Tobago in 1977 to that in 1980?
Provide a short and direct response. 0.91. What is the ratio of the Population growth (in %) in Other small states in 1978 to that in 1979?
Ensure brevity in your answer.  0.92. What is the ratio of the Population growth (in %) of Egypt, Arab Rep. in 1978 to that in 1979?
Give a very brief answer. 0.97. What is the ratio of the Population growth (in %) in Trinidad and Tobago in 1978 to that in 1979?
Your response must be concise. 0.97. What is the ratio of the Population growth (in %) in Other small states in 1978 to that in 1980?
Your response must be concise. 0.89. What is the ratio of the Population growth (in %) of Trinidad and Tobago in 1978 to that in 1980?
Keep it short and to the point. 0.91. What is the ratio of the Population growth (in %) of Other small states in 1979 to that in 1980?
Your answer should be very brief. 0.96. What is the ratio of the Population growth (in %) of Egypt, Arab Rep. in 1979 to that in 1980?
Ensure brevity in your answer.  0.97. What is the ratio of the Population growth (in %) of Trinidad and Tobago in 1979 to that in 1980?
Ensure brevity in your answer.  0.94. What is the difference between the highest and the second highest Population growth (in %) in Other small states?
Provide a succinct answer. 0.01. What is the difference between the highest and the second highest Population growth (in %) in Egypt, Arab Rep.?
Make the answer very short. 0.06. What is the difference between the highest and the second highest Population growth (in %) of Trinidad and Tobago?
Offer a very short reply. 0.06. What is the difference between the highest and the lowest Population growth (in %) of Other small states?
Keep it short and to the point. 0.18. What is the difference between the highest and the lowest Population growth (in %) in Egypt, Arab Rep.?
Ensure brevity in your answer.  1.02. What is the difference between the highest and the lowest Population growth (in %) of Trinidad and Tobago?
Provide a short and direct response. 0.15. 